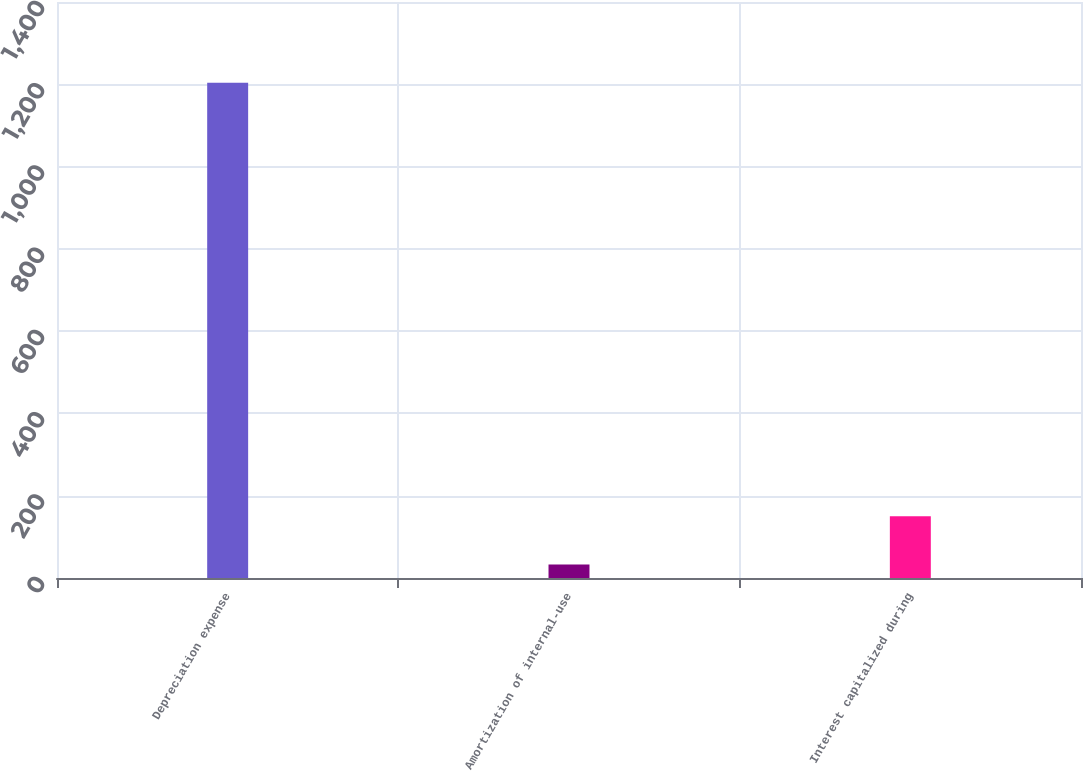Convert chart. <chart><loc_0><loc_0><loc_500><loc_500><bar_chart><fcel>Depreciation expense<fcel>Amortization of internal-use<fcel>Interest capitalized during<nl><fcel>1204<fcel>33<fcel>150.1<nl></chart> 